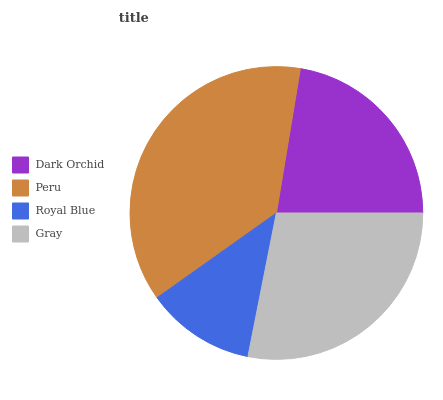Is Royal Blue the minimum?
Answer yes or no. Yes. Is Peru the maximum?
Answer yes or no. Yes. Is Peru the minimum?
Answer yes or no. No. Is Royal Blue the maximum?
Answer yes or no. No. Is Peru greater than Royal Blue?
Answer yes or no. Yes. Is Royal Blue less than Peru?
Answer yes or no. Yes. Is Royal Blue greater than Peru?
Answer yes or no. No. Is Peru less than Royal Blue?
Answer yes or no. No. Is Gray the high median?
Answer yes or no. Yes. Is Dark Orchid the low median?
Answer yes or no. Yes. Is Peru the high median?
Answer yes or no. No. Is Royal Blue the low median?
Answer yes or no. No. 